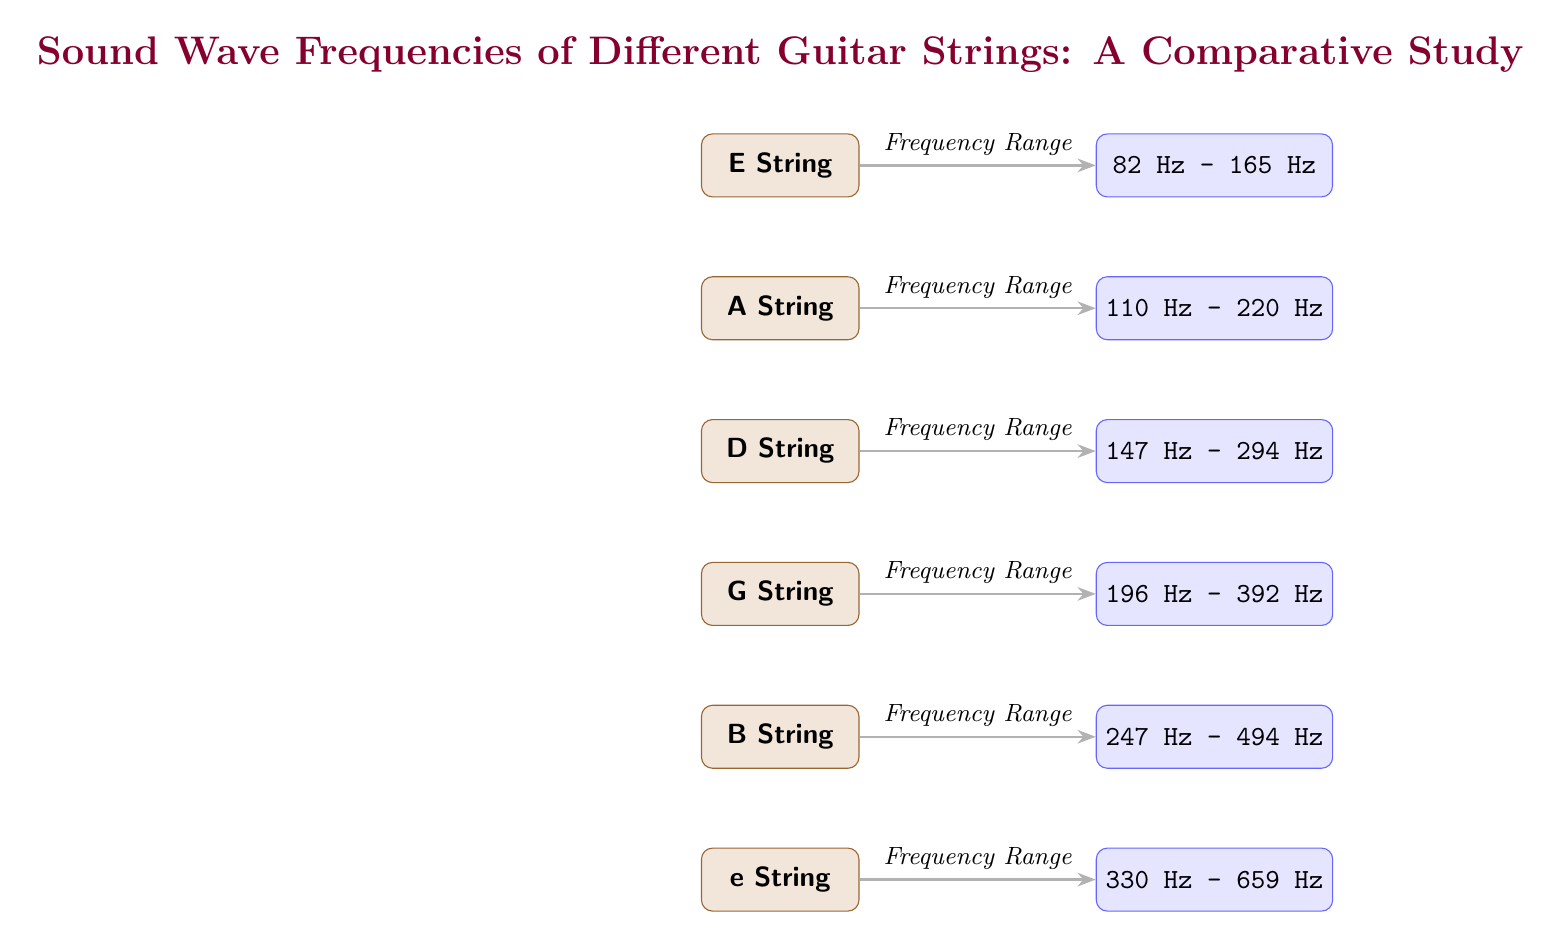What is the frequency range of the E String? The diagram displays a node labeled "E String" connected by an arrow to the frequency range "82 Hz - 165 Hz".
Answer: 82 Hz - 165 Hz How many guitar strings are represented in the diagram? By counting the nodes labeled for guitar strings from E to e, there are a total of six strings shown in the diagram.
Answer: 6 What is the frequency range of the A String? The A String node connects to the frequency range "110 Hz - 220 Hz", as indicated by the arrow pointing to that frequency range.
Answer: 110 Hz - 220 Hz Which guitar string has a frequency range starting at 247 Hz? Looking at the frequency ranges next to the guitar strings, the "B String" is connected to the frequency range "247 Hz - 494 Hz", thus it starts at 247 Hz.
Answer: B String What is the highest frequency range shown in the diagram? By analyzing the frequency ranges, the "e String" has the highest range of "330 Hz - 659 Hz", making it the highest in value within this diagram.
Answer: 330 Hz - 659 Hz What string has a frequency range equivalent to 196 Hz - 392 Hz? The string connected to this specific frequency range is the "G String", as indicated by the corresponding node and arrow displaying its range.
Answer: G String Which guitar string has a frequency range that first goes up to 294 Hz? The "D String" is connected to the frequency range "147 Hz - 294 Hz", indicating it is the only string with that upper limit.
Answer: D String What is the frequency range relationship between the A String and the D String? When analyzing the diagram, the A String has a frequency range of "110 Hz - 220 Hz" while the D String has "147 Hz - 294 Hz", showing that the D String begins at a frequency higher than that of the A String’s upper limit.
Answer: D String starts higher Which guitar string has the lowest frequency range? In the diagram, the E String has the lowest frequency range of "82 Hz - 165 Hz" among all the strings displayed.
Answer: E String 